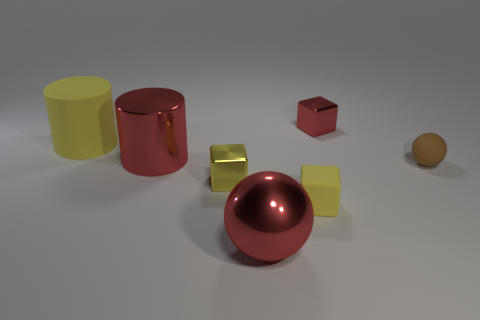There is a big thing that is in front of the thing that is right of the metal cube behind the matte ball; what is its material?
Give a very brief answer. Metal. There is a large red metallic object in front of the tiny yellow metallic thing; what is its shape?
Ensure brevity in your answer.  Sphere. There is a brown object that is the same material as the large yellow thing; what is its size?
Make the answer very short. Small. What number of other things are the same shape as the brown rubber object?
Keep it short and to the point. 1. There is a matte thing on the left side of the big metal cylinder; is its color the same as the big metal cylinder?
Provide a short and direct response. No. There is a matte thing on the right side of the small metallic block behind the yellow cylinder; how many small yellow matte cubes are in front of it?
Ensure brevity in your answer.  1. How many tiny metal cubes are in front of the tiny matte sphere and behind the big shiny cylinder?
Your answer should be compact. 0. What shape is the large thing that is the same color as the big shiny ball?
Make the answer very short. Cylinder. Is there anything else that has the same material as the small brown thing?
Make the answer very short. Yes. Is the material of the brown thing the same as the red block?
Make the answer very short. No. 